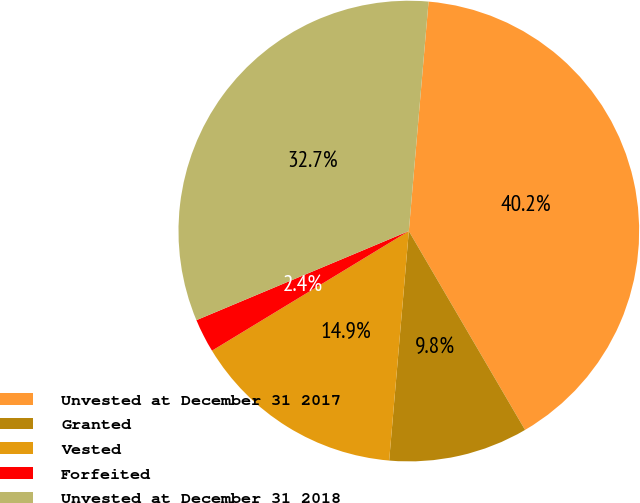Convert chart. <chart><loc_0><loc_0><loc_500><loc_500><pie_chart><fcel>Unvested at December 31 2017<fcel>Granted<fcel>Vested<fcel>Forfeited<fcel>Unvested at December 31 2018<nl><fcel>40.22%<fcel>9.78%<fcel>14.95%<fcel>2.37%<fcel>32.69%<nl></chart> 